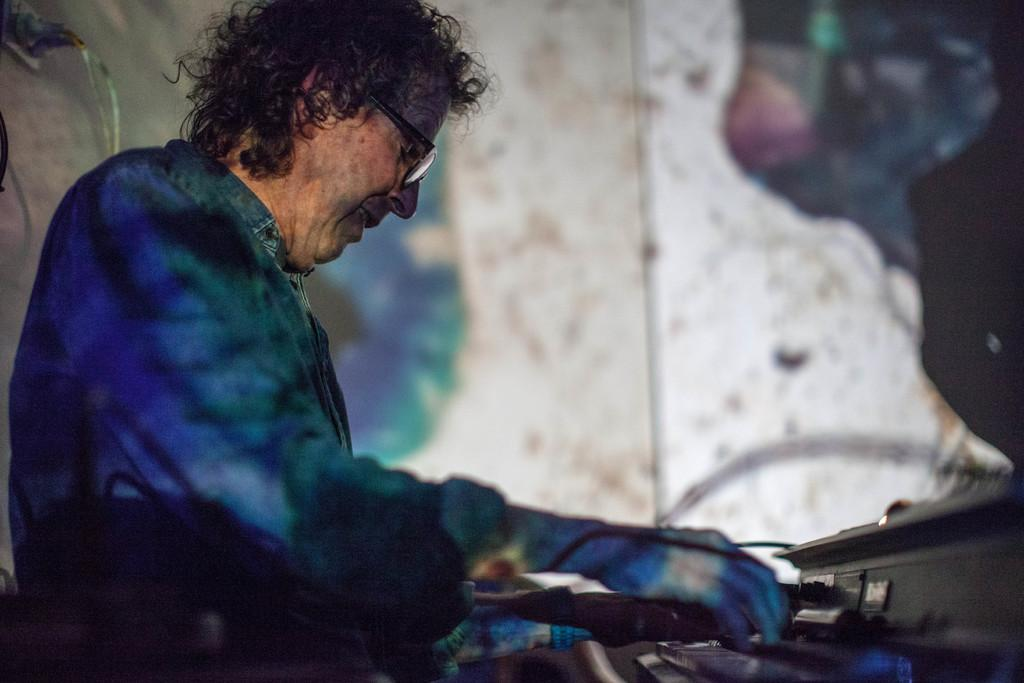What is the main subject of the image? There is a person in the image. What is the person wearing? The person is wearing a blue dress and glasses (specs). What is the person doing or standing near in the image? The person is in front of a musical instrument. What can be seen in the background of the image? There is a wall in the background of the image. What type of plant is growing on the person's face in the image? There is no plant growing on the person's face in the image. How many plants are visible in the image? There are no plants visible in the image; only a person, a musical instrument, and a wall are present. 